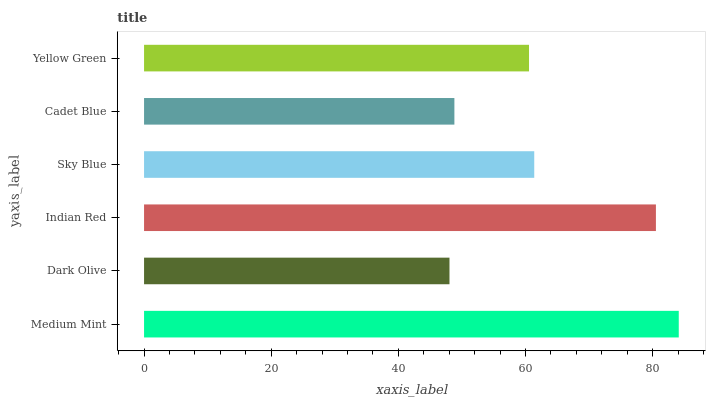Is Dark Olive the minimum?
Answer yes or no. Yes. Is Medium Mint the maximum?
Answer yes or no. Yes. Is Indian Red the minimum?
Answer yes or no. No. Is Indian Red the maximum?
Answer yes or no. No. Is Indian Red greater than Dark Olive?
Answer yes or no. Yes. Is Dark Olive less than Indian Red?
Answer yes or no. Yes. Is Dark Olive greater than Indian Red?
Answer yes or no. No. Is Indian Red less than Dark Olive?
Answer yes or no. No. Is Sky Blue the high median?
Answer yes or no. Yes. Is Yellow Green the low median?
Answer yes or no. Yes. Is Cadet Blue the high median?
Answer yes or no. No. Is Sky Blue the low median?
Answer yes or no. No. 